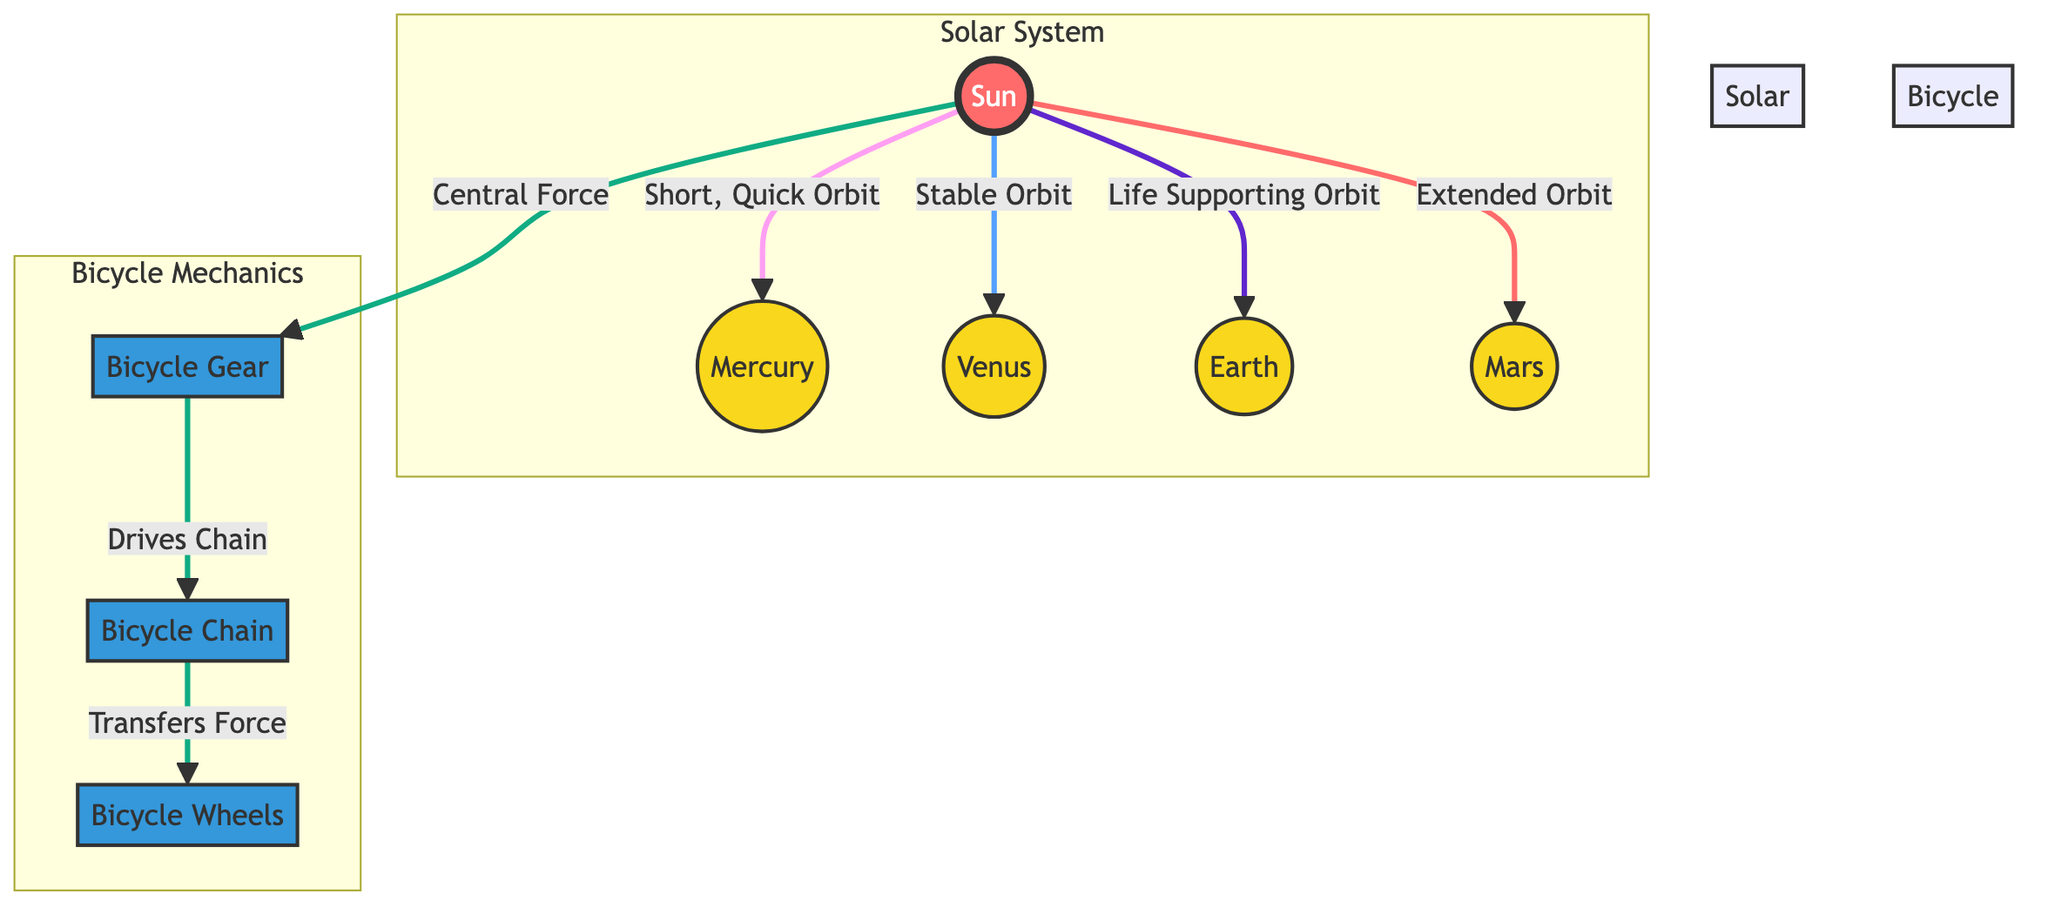What's at the center of the solar system? The diagram shows the Sun at the center of the solar system subgraph as the primary object around which the planets orbit.
Answer: Sun Which planet is associated with a "Life Supporting Orbit"? The diagram indicates that Earth is specifically associated with the label "Life Supporting Orbit," highlighting its nature in the solar system.
Answer: Earth How many planets are shown in the solar system? The diagram lists four planets: Mercury, Venus, Earth, and Mars, contributing to the total count shown within the solar system subgraph.
Answer: Four What does the gear drive in bicycle mechanics? The diagram connects the gear, indicating that it drives the chain in the bicycle mechanics subgraph, reflecting the relationship between components in the system.
Answer: Chain Which planet has an "Extended Orbit"? The diagram states that Mars has an "Extended Orbit," showing the varying distances and mechanics among the planets in their orbits around the Sun.
Answer: Mars What primary force acts on the gear in bicycle mechanics? According to the diagram, the Sun is described as a "Central Force," which drives the mechanics of the gear in bicycle systems, paralleling the interactions in both systems.
Answer: Central Force Which planet has the "Short, Quick Orbit"? The diagram specifies that Mercury has a "Short, Quick Orbit," differentiating its orbital characteristics from those of other planets.
Answer: Mercury How does the chain interact in the bicycle mechanics? The diagram illustrates that the chain "Transfers Force" from the gear to the wheels, emphasizing its role in the bicycle propulsion system.
Answer: Transfers Force What color represents the planets in the diagram? A visual analysis of the diagram shows that planets are represented with a specific yellow fill color, as indicated by the class definition.
Answer: Yellow 